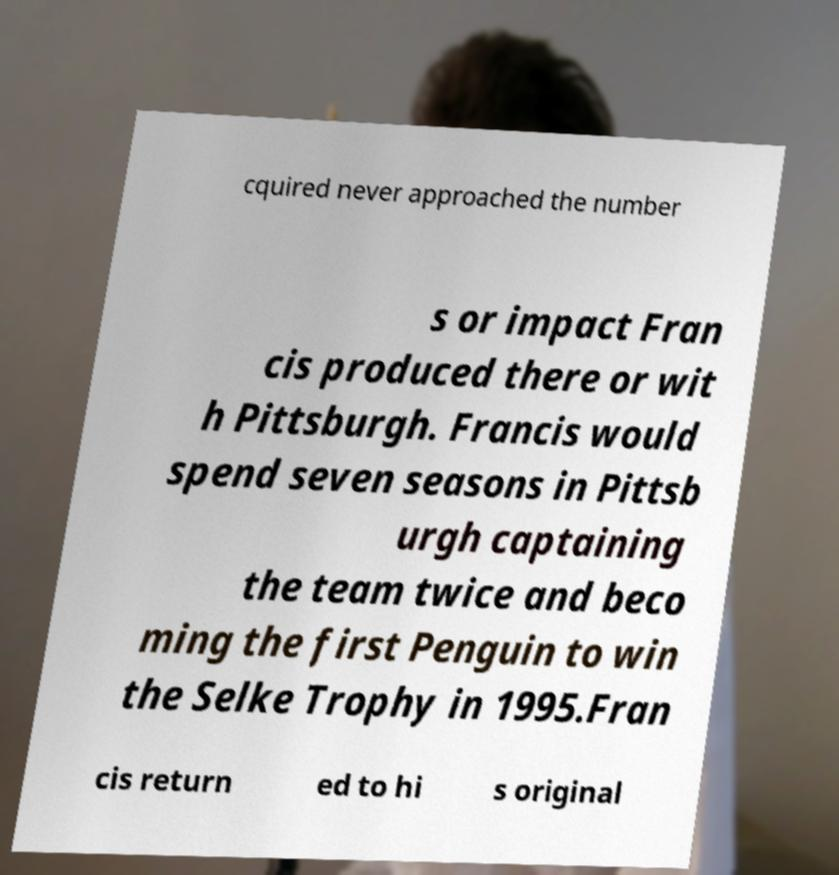Please identify and transcribe the text found in this image. cquired never approached the number s or impact Fran cis produced there or wit h Pittsburgh. Francis would spend seven seasons in Pittsb urgh captaining the team twice and beco ming the first Penguin to win the Selke Trophy in 1995.Fran cis return ed to hi s original 